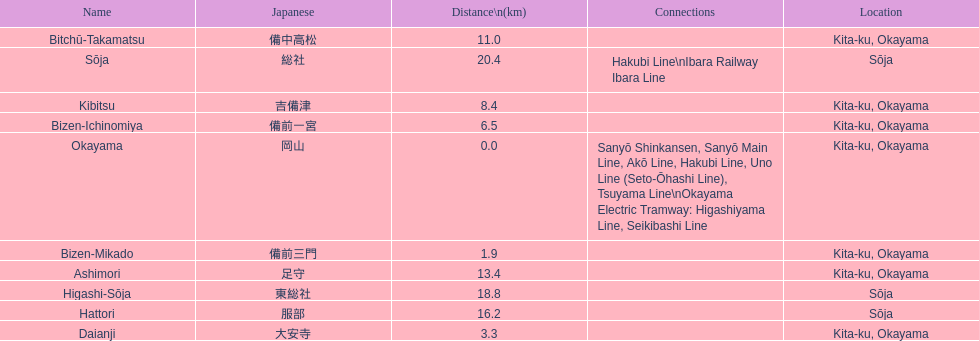How many consecutive stops must you travel through is you board the kibi line at bizen-mikado at depart at kibitsu? 2. 